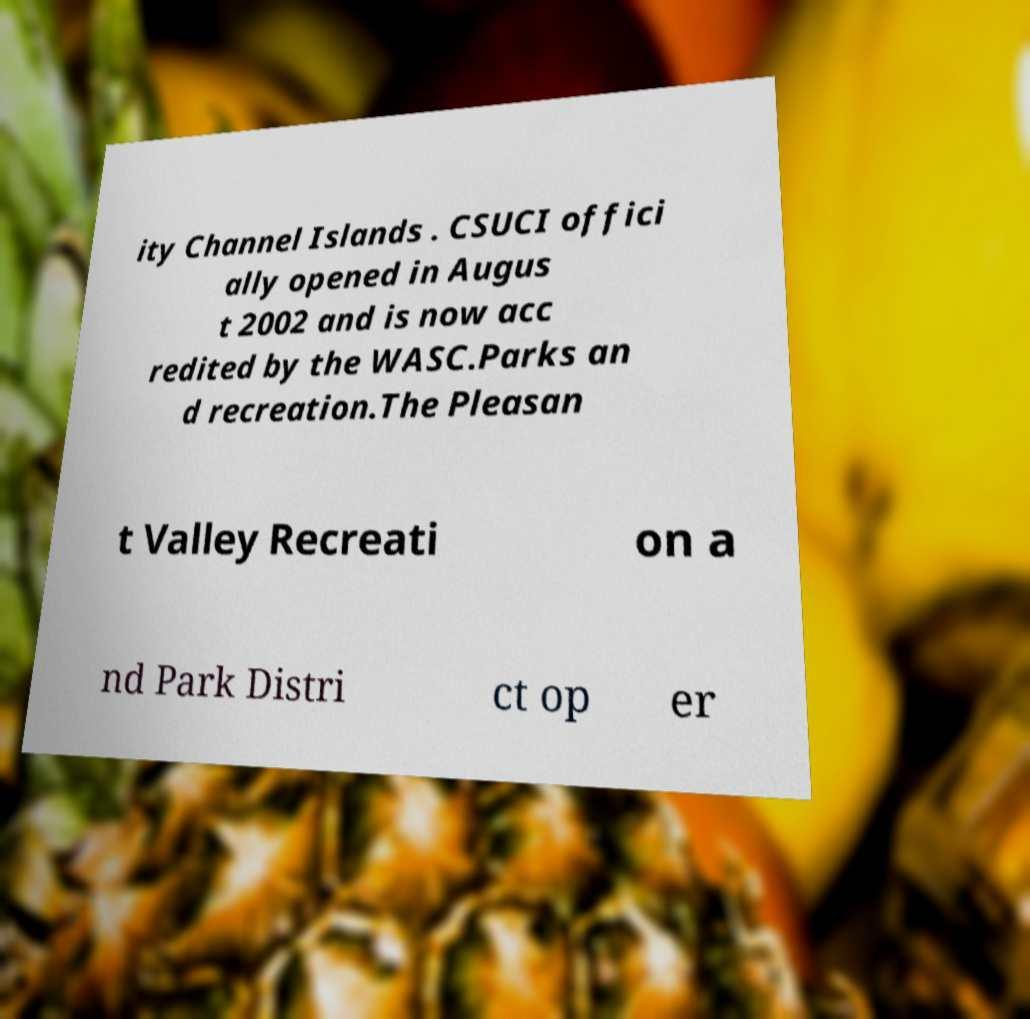There's text embedded in this image that I need extracted. Can you transcribe it verbatim? ity Channel Islands . CSUCI offici ally opened in Augus t 2002 and is now acc redited by the WASC.Parks an d recreation.The Pleasan t Valley Recreati on a nd Park Distri ct op er 